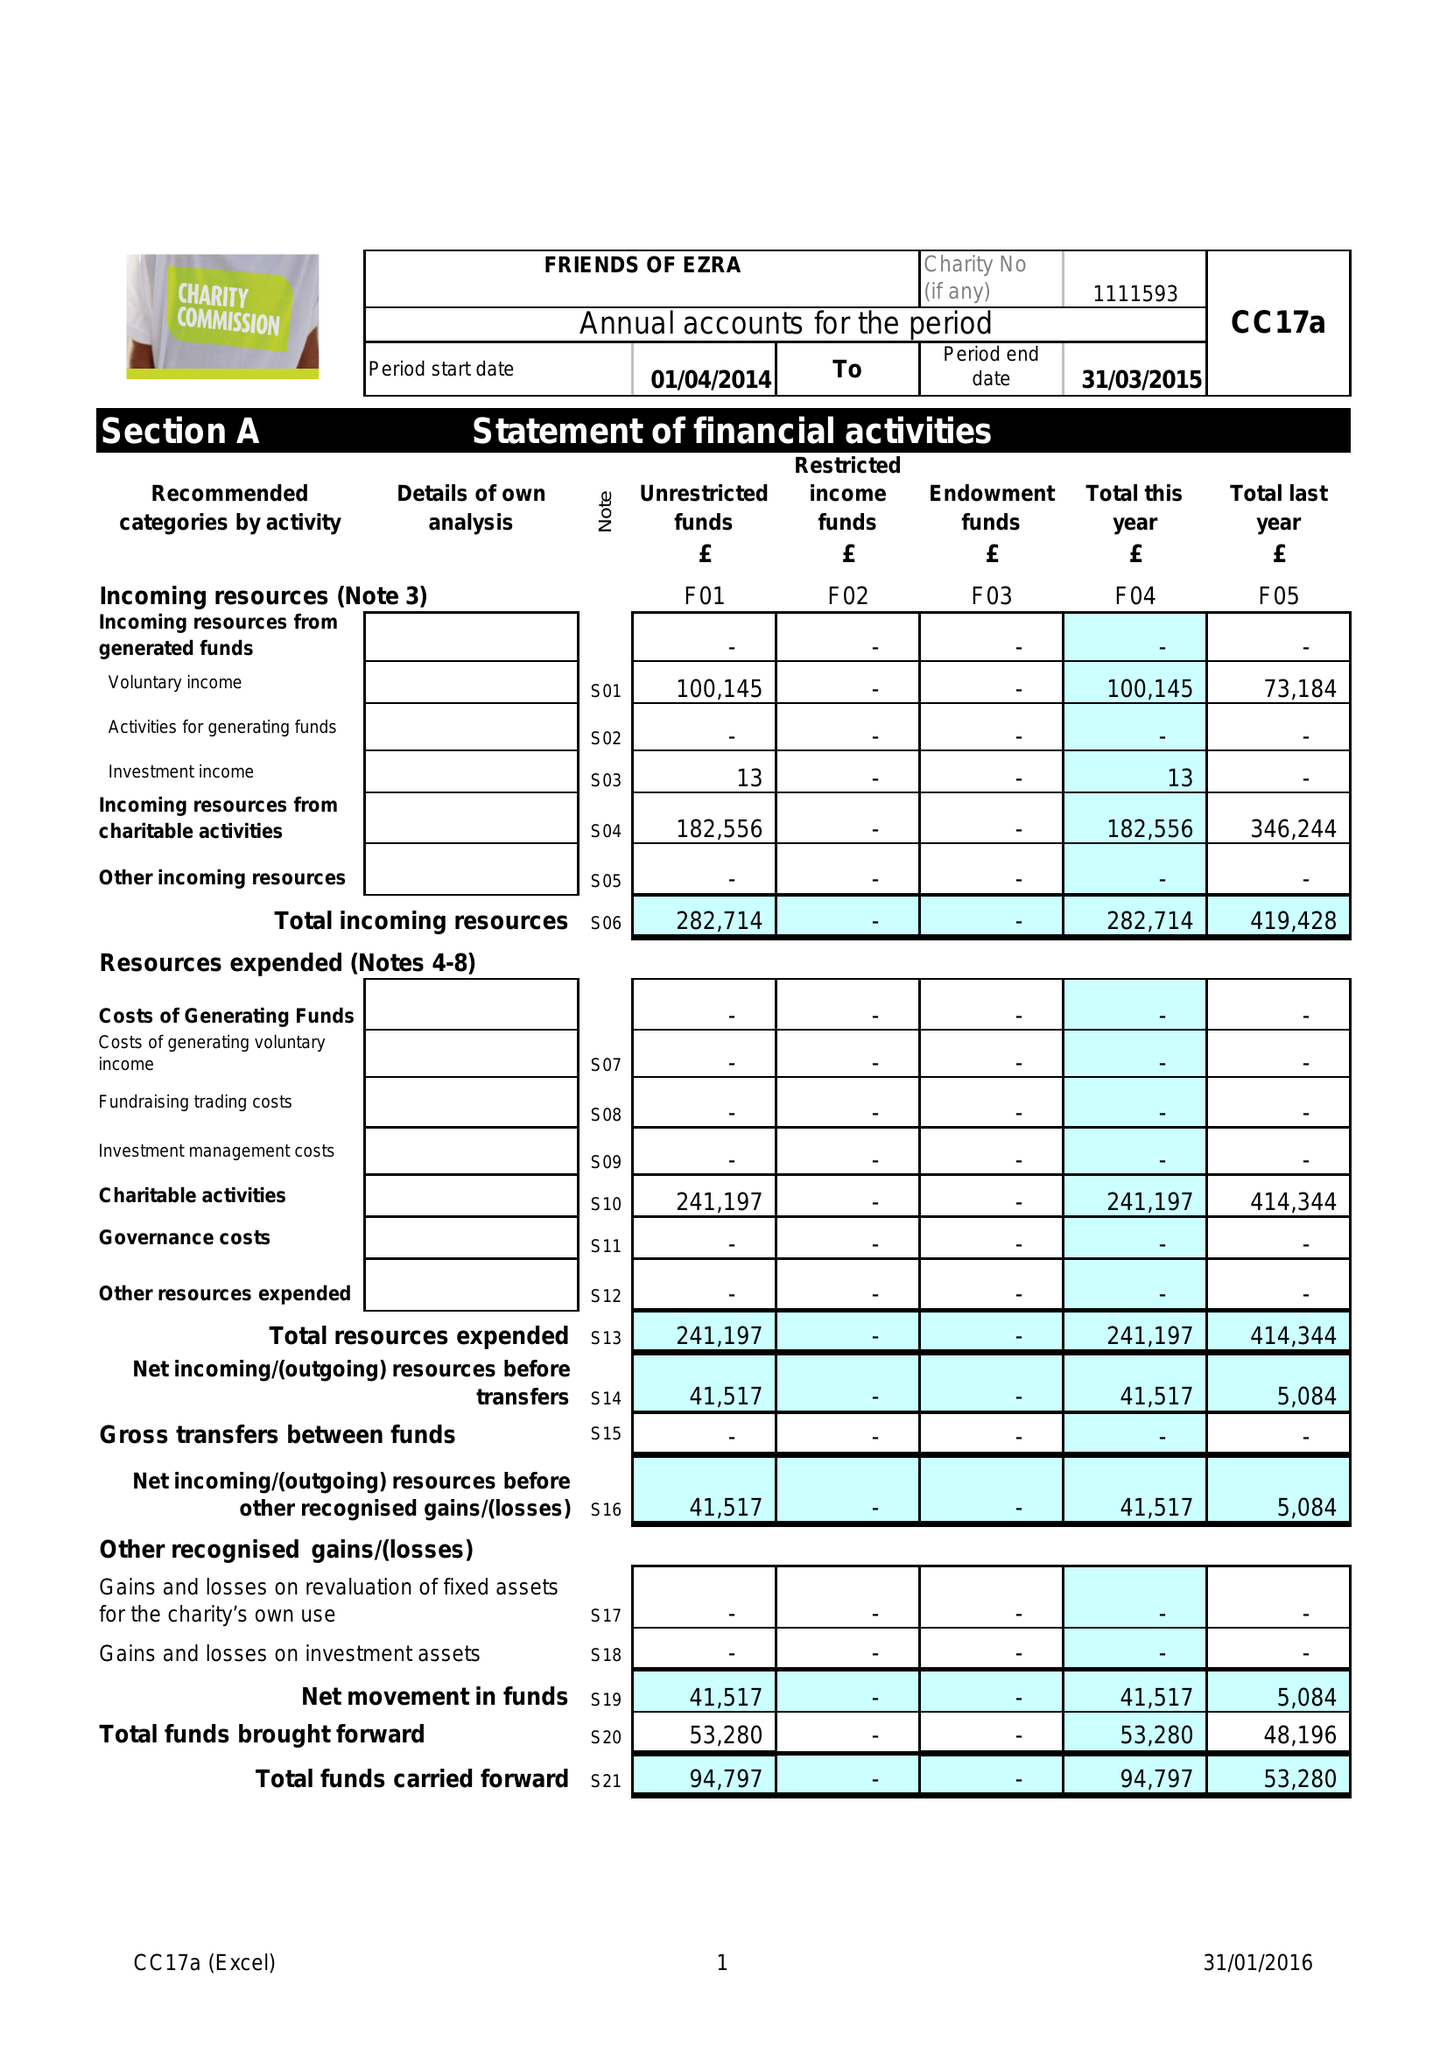What is the value for the income_annually_in_british_pounds?
Answer the question using a single word or phrase. 282714.00 